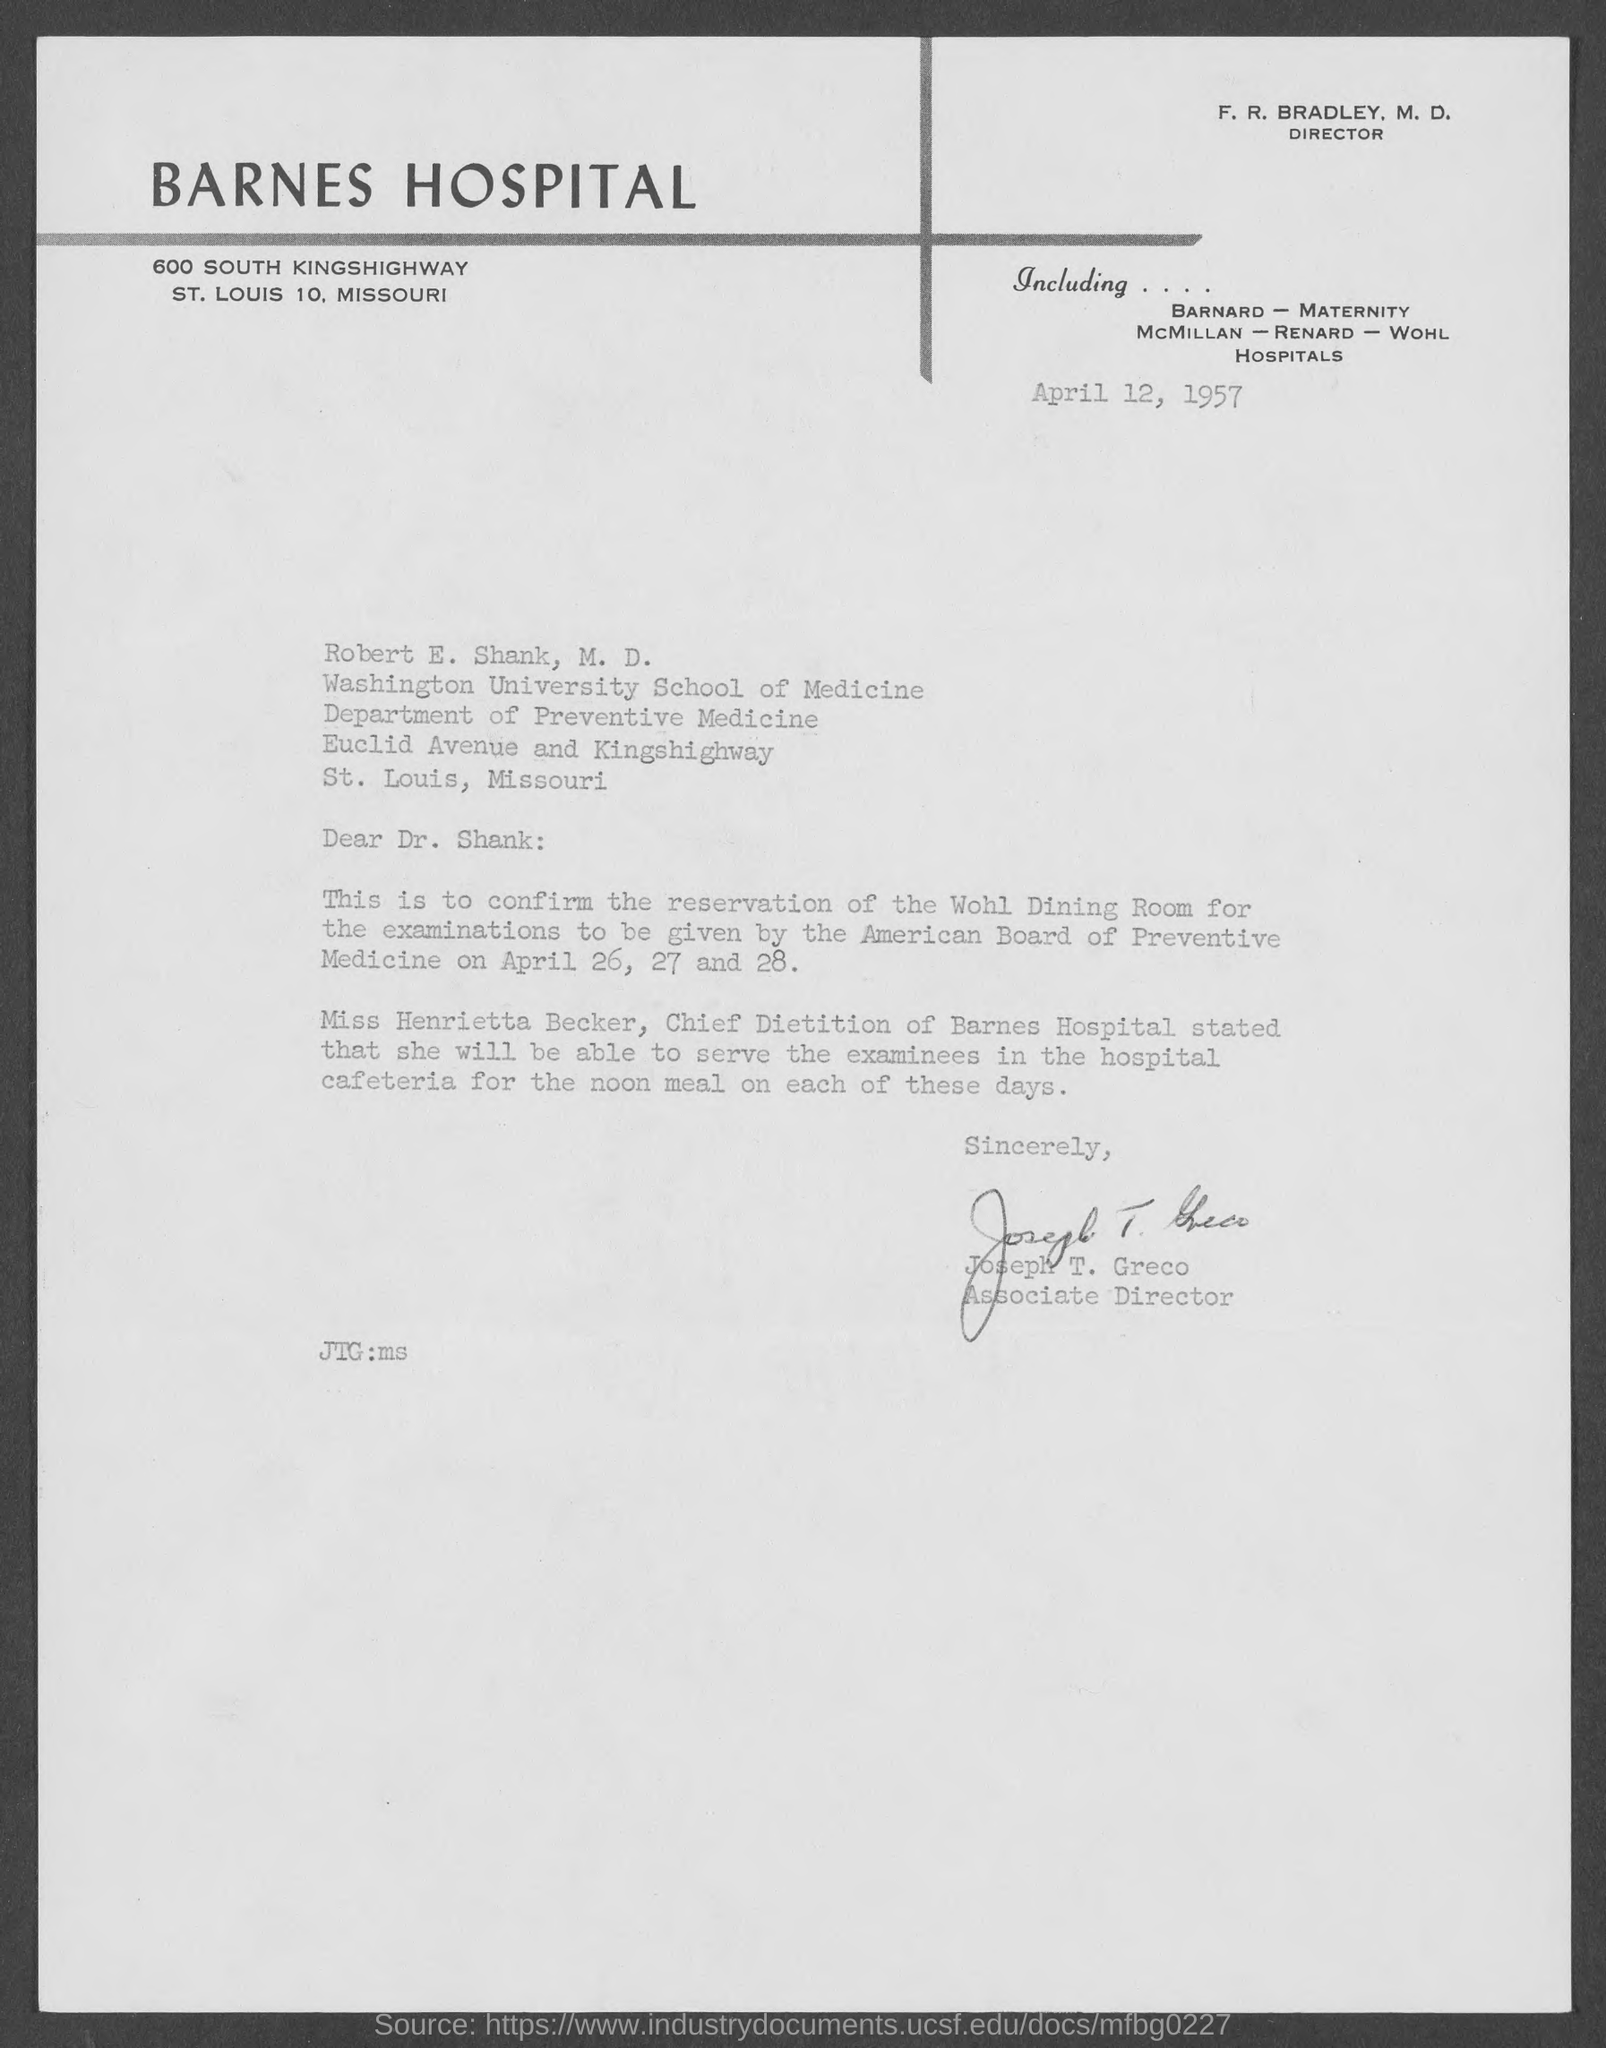Identify some key points in this picture. The value written in the "JTG" field is milliseconds. The Associate Director is Joseph T. Greco. The date mentioned at the top of the document is April 12, 1957. 